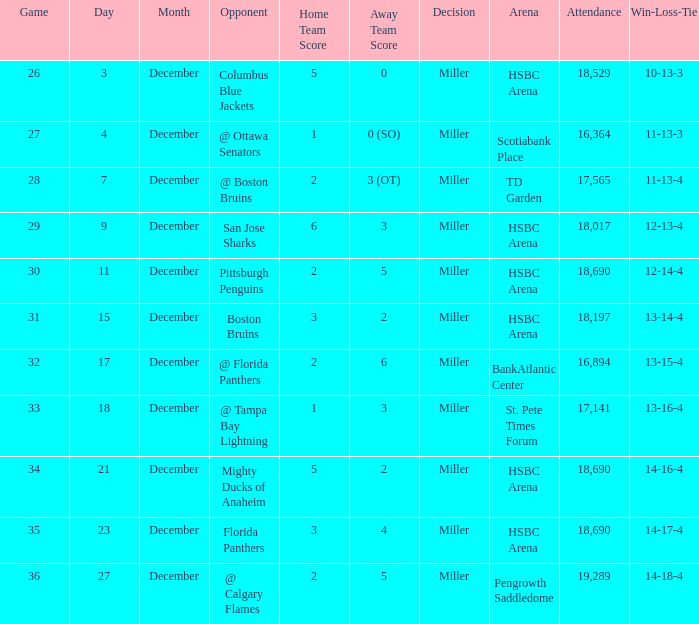Can you give me this table as a dict? {'header': ['Game', 'Day', 'Month', 'Opponent', 'Home Team Score', 'Away Team Score', 'Decision', 'Arena', 'Attendance', 'Win-Loss-Tie'], 'rows': [['26', '3', 'December', 'Columbus Blue Jackets', '5', '0', 'Miller', 'HSBC Arena', '18,529', '10-13-3'], ['27', '4', 'December', '@ Ottawa Senators', '1', '0 (SO)', 'Miller', 'Scotiabank Place', '16,364', '11-13-3'], ['28', '7', 'December', '@ Boston Bruins', '2', '3 (OT)', 'Miller', 'TD Garden', '17,565', '11-13-4'], ['29', '9', 'December', 'San Jose Sharks', '6', '3', 'Miller', 'HSBC Arena', '18,017', '12-13-4'], ['30', '11', 'December', 'Pittsburgh Penguins', '2', '5', 'Miller', 'HSBC Arena', '18,690', '12-14-4'], ['31', '15', 'December', 'Boston Bruins', '3', '2', 'Miller', 'HSBC Arena', '18,197', '13-14-4'], ['32', '17', 'December', '@ Florida Panthers', '2', '6', 'Miller', 'BankAtlantic Center', '16,894', '13-15-4'], ['33', '18', 'December', '@ Tampa Bay Lightning', '1', '3', 'Miller', 'St. Pete Times Forum', '17,141', '13-16-4'], ['34', '21', 'December', 'Mighty Ducks of Anaheim', '5', '2', 'Miller', 'HSBC Arena', '18,690', '14-16-4'], ['35', '23', 'December', 'Florida Panthers', '3', '4', 'Miller', 'HSBC Arena', '18,690', '14-17-4'], ['36', '27', 'December', '@ Calgary Flames', '2', '5', 'Miller', 'Pengrowth Saddledome', '19,289', '14-18-4']]} Name the least december for hsbc arena/18,017 9.0. 